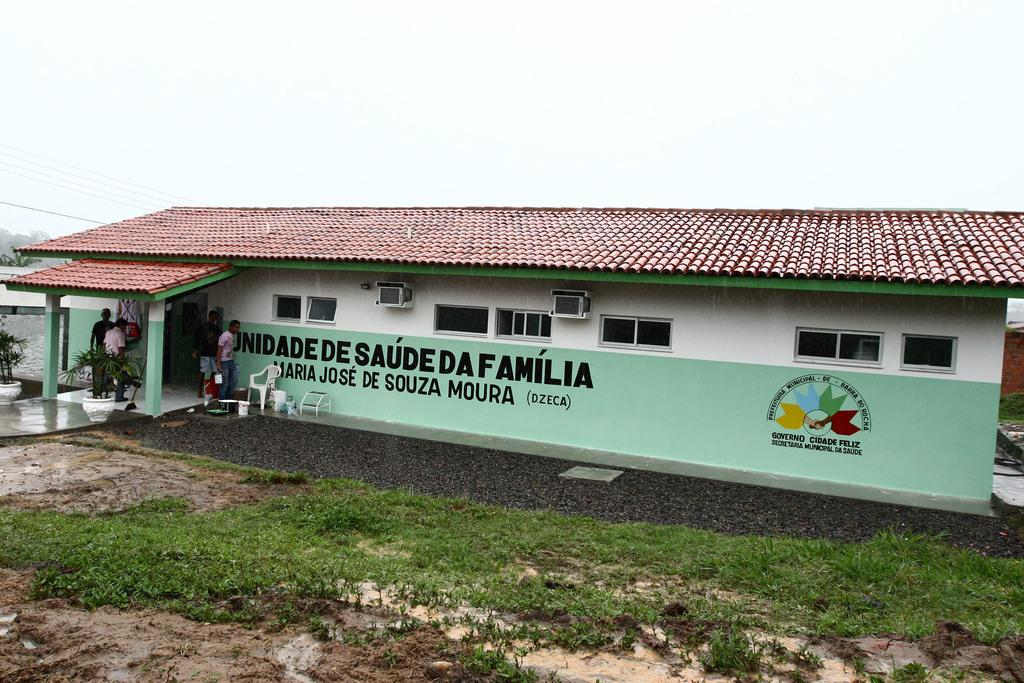What type of structure is in the image? There is a house in the image. What are the people near the house doing? The people are standing at the entrances of the house. What type of vegetation is visible near the house? There is grass visible near the house. Can you see the carpenter's finger in the image? There is no carpenter or finger present in the image. What type of quiver is visible near the house? There is no quiver present in the image. 